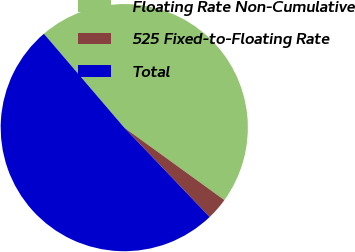Convert chart. <chart><loc_0><loc_0><loc_500><loc_500><pie_chart><fcel>Floating Rate Non-Cumulative<fcel>525 Fixed-to-Floating Rate<fcel>Total<nl><fcel>46.24%<fcel>2.89%<fcel>50.87%<nl></chart> 